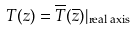<formula> <loc_0><loc_0><loc_500><loc_500>T ( z ) = \overline { T } ( \overline { z } ) \mathcal { j } _ { \text {real axis} }</formula> 